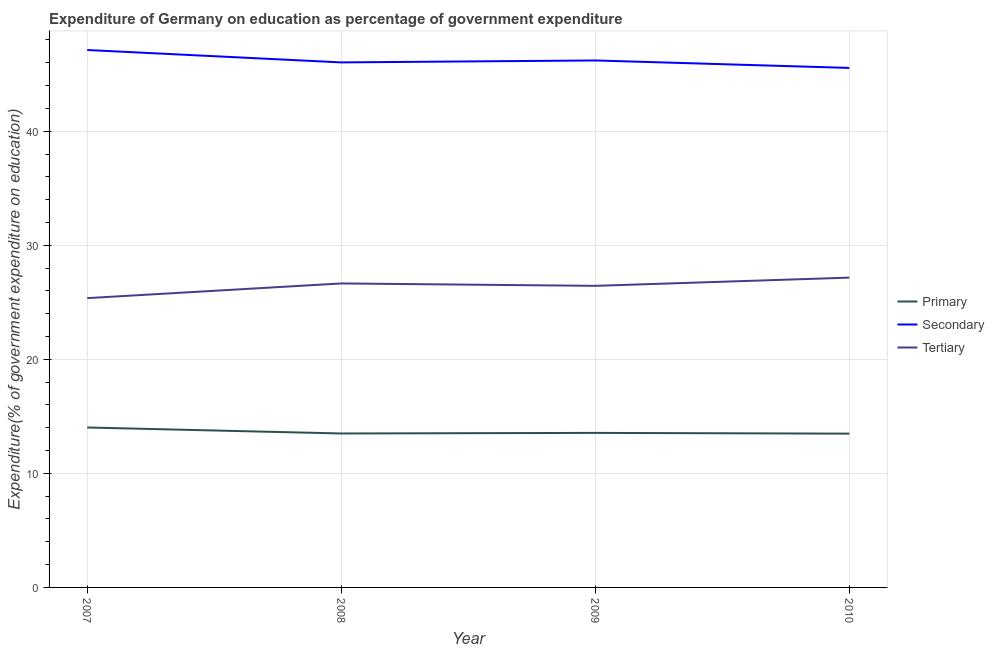Does the line corresponding to expenditure on secondary education intersect with the line corresponding to expenditure on primary education?
Keep it short and to the point. No. What is the expenditure on secondary education in 2007?
Offer a very short reply. 47.12. Across all years, what is the maximum expenditure on primary education?
Give a very brief answer. 14.02. Across all years, what is the minimum expenditure on primary education?
Keep it short and to the point. 13.48. In which year was the expenditure on tertiary education maximum?
Offer a terse response. 2010. In which year was the expenditure on tertiary education minimum?
Give a very brief answer. 2007. What is the total expenditure on tertiary education in the graph?
Give a very brief answer. 105.62. What is the difference between the expenditure on secondary education in 2007 and that in 2010?
Offer a very short reply. 1.57. What is the difference between the expenditure on primary education in 2007 and the expenditure on tertiary education in 2008?
Offer a very short reply. -12.63. What is the average expenditure on primary education per year?
Provide a short and direct response. 13.64. In the year 2009, what is the difference between the expenditure on secondary education and expenditure on tertiary education?
Offer a very short reply. 19.76. In how many years, is the expenditure on primary education greater than 12 %?
Offer a very short reply. 4. What is the ratio of the expenditure on secondary education in 2009 to that in 2010?
Ensure brevity in your answer.  1.01. Is the expenditure on tertiary education in 2008 less than that in 2010?
Your answer should be very brief. Yes. Is the difference between the expenditure on secondary education in 2009 and 2010 greater than the difference between the expenditure on primary education in 2009 and 2010?
Make the answer very short. Yes. What is the difference between the highest and the second highest expenditure on secondary education?
Keep it short and to the point. 0.92. What is the difference between the highest and the lowest expenditure on primary education?
Offer a terse response. 0.54. In how many years, is the expenditure on primary education greater than the average expenditure on primary education taken over all years?
Provide a succinct answer. 1. Is the sum of the expenditure on tertiary education in 2008 and 2010 greater than the maximum expenditure on secondary education across all years?
Offer a very short reply. Yes. Is the expenditure on primary education strictly greater than the expenditure on tertiary education over the years?
Your answer should be compact. No. Are the values on the major ticks of Y-axis written in scientific E-notation?
Make the answer very short. No. Does the graph contain any zero values?
Offer a very short reply. No. What is the title of the graph?
Provide a succinct answer. Expenditure of Germany on education as percentage of government expenditure. Does "Industry" appear as one of the legend labels in the graph?
Your answer should be compact. No. What is the label or title of the X-axis?
Give a very brief answer. Year. What is the label or title of the Y-axis?
Offer a very short reply. Expenditure(% of government expenditure on education). What is the Expenditure(% of government expenditure on education) in Primary in 2007?
Your response must be concise. 14.02. What is the Expenditure(% of government expenditure on education) in Secondary in 2007?
Your answer should be compact. 47.12. What is the Expenditure(% of government expenditure on education) of Tertiary in 2007?
Your response must be concise. 25.36. What is the Expenditure(% of government expenditure on education) in Primary in 2008?
Your answer should be very brief. 13.5. What is the Expenditure(% of government expenditure on education) in Secondary in 2008?
Keep it short and to the point. 46.03. What is the Expenditure(% of government expenditure on education) of Tertiary in 2008?
Provide a short and direct response. 26.65. What is the Expenditure(% of government expenditure on education) in Primary in 2009?
Keep it short and to the point. 13.55. What is the Expenditure(% of government expenditure on education) in Secondary in 2009?
Give a very brief answer. 46.2. What is the Expenditure(% of government expenditure on education) of Tertiary in 2009?
Provide a short and direct response. 26.44. What is the Expenditure(% of government expenditure on education) in Primary in 2010?
Ensure brevity in your answer.  13.48. What is the Expenditure(% of government expenditure on education) of Secondary in 2010?
Ensure brevity in your answer.  45.55. What is the Expenditure(% of government expenditure on education) of Tertiary in 2010?
Your answer should be compact. 27.16. Across all years, what is the maximum Expenditure(% of government expenditure on education) in Primary?
Ensure brevity in your answer.  14.02. Across all years, what is the maximum Expenditure(% of government expenditure on education) of Secondary?
Provide a short and direct response. 47.12. Across all years, what is the maximum Expenditure(% of government expenditure on education) in Tertiary?
Make the answer very short. 27.16. Across all years, what is the minimum Expenditure(% of government expenditure on education) of Primary?
Keep it short and to the point. 13.48. Across all years, what is the minimum Expenditure(% of government expenditure on education) in Secondary?
Keep it short and to the point. 45.55. Across all years, what is the minimum Expenditure(% of government expenditure on education) of Tertiary?
Ensure brevity in your answer.  25.36. What is the total Expenditure(% of government expenditure on education) in Primary in the graph?
Give a very brief answer. 54.55. What is the total Expenditure(% of government expenditure on education) in Secondary in the graph?
Give a very brief answer. 184.9. What is the total Expenditure(% of government expenditure on education) of Tertiary in the graph?
Your answer should be compact. 105.62. What is the difference between the Expenditure(% of government expenditure on education) of Primary in 2007 and that in 2008?
Offer a very short reply. 0.53. What is the difference between the Expenditure(% of government expenditure on education) of Secondary in 2007 and that in 2008?
Your answer should be very brief. 1.09. What is the difference between the Expenditure(% of government expenditure on education) of Tertiary in 2007 and that in 2008?
Your response must be concise. -1.29. What is the difference between the Expenditure(% of government expenditure on education) in Primary in 2007 and that in 2009?
Keep it short and to the point. 0.47. What is the difference between the Expenditure(% of government expenditure on education) in Secondary in 2007 and that in 2009?
Give a very brief answer. 0.92. What is the difference between the Expenditure(% of government expenditure on education) of Tertiary in 2007 and that in 2009?
Your answer should be compact. -1.08. What is the difference between the Expenditure(% of government expenditure on education) in Primary in 2007 and that in 2010?
Offer a terse response. 0.54. What is the difference between the Expenditure(% of government expenditure on education) in Secondary in 2007 and that in 2010?
Give a very brief answer. 1.57. What is the difference between the Expenditure(% of government expenditure on education) of Tertiary in 2007 and that in 2010?
Your answer should be very brief. -1.8. What is the difference between the Expenditure(% of government expenditure on education) in Primary in 2008 and that in 2009?
Provide a short and direct response. -0.05. What is the difference between the Expenditure(% of government expenditure on education) in Secondary in 2008 and that in 2009?
Offer a very short reply. -0.17. What is the difference between the Expenditure(% of government expenditure on education) in Tertiary in 2008 and that in 2009?
Provide a short and direct response. 0.21. What is the difference between the Expenditure(% of government expenditure on education) of Primary in 2008 and that in 2010?
Your answer should be very brief. 0.01. What is the difference between the Expenditure(% of government expenditure on education) of Secondary in 2008 and that in 2010?
Your answer should be compact. 0.48. What is the difference between the Expenditure(% of government expenditure on education) in Tertiary in 2008 and that in 2010?
Provide a succinct answer. -0.51. What is the difference between the Expenditure(% of government expenditure on education) in Primary in 2009 and that in 2010?
Offer a terse response. 0.07. What is the difference between the Expenditure(% of government expenditure on education) of Secondary in 2009 and that in 2010?
Make the answer very short. 0.66. What is the difference between the Expenditure(% of government expenditure on education) in Tertiary in 2009 and that in 2010?
Ensure brevity in your answer.  -0.72. What is the difference between the Expenditure(% of government expenditure on education) in Primary in 2007 and the Expenditure(% of government expenditure on education) in Secondary in 2008?
Your answer should be very brief. -32.01. What is the difference between the Expenditure(% of government expenditure on education) of Primary in 2007 and the Expenditure(% of government expenditure on education) of Tertiary in 2008?
Your response must be concise. -12.63. What is the difference between the Expenditure(% of government expenditure on education) of Secondary in 2007 and the Expenditure(% of government expenditure on education) of Tertiary in 2008?
Your answer should be very brief. 20.47. What is the difference between the Expenditure(% of government expenditure on education) of Primary in 2007 and the Expenditure(% of government expenditure on education) of Secondary in 2009?
Keep it short and to the point. -32.18. What is the difference between the Expenditure(% of government expenditure on education) in Primary in 2007 and the Expenditure(% of government expenditure on education) in Tertiary in 2009?
Keep it short and to the point. -12.42. What is the difference between the Expenditure(% of government expenditure on education) of Secondary in 2007 and the Expenditure(% of government expenditure on education) of Tertiary in 2009?
Make the answer very short. 20.68. What is the difference between the Expenditure(% of government expenditure on education) of Primary in 2007 and the Expenditure(% of government expenditure on education) of Secondary in 2010?
Keep it short and to the point. -31.52. What is the difference between the Expenditure(% of government expenditure on education) of Primary in 2007 and the Expenditure(% of government expenditure on education) of Tertiary in 2010?
Your answer should be compact. -13.14. What is the difference between the Expenditure(% of government expenditure on education) of Secondary in 2007 and the Expenditure(% of government expenditure on education) of Tertiary in 2010?
Give a very brief answer. 19.96. What is the difference between the Expenditure(% of government expenditure on education) in Primary in 2008 and the Expenditure(% of government expenditure on education) in Secondary in 2009?
Your answer should be very brief. -32.71. What is the difference between the Expenditure(% of government expenditure on education) of Primary in 2008 and the Expenditure(% of government expenditure on education) of Tertiary in 2009?
Offer a very short reply. -12.94. What is the difference between the Expenditure(% of government expenditure on education) in Secondary in 2008 and the Expenditure(% of government expenditure on education) in Tertiary in 2009?
Provide a succinct answer. 19.59. What is the difference between the Expenditure(% of government expenditure on education) in Primary in 2008 and the Expenditure(% of government expenditure on education) in Secondary in 2010?
Provide a succinct answer. -32.05. What is the difference between the Expenditure(% of government expenditure on education) of Primary in 2008 and the Expenditure(% of government expenditure on education) of Tertiary in 2010?
Your response must be concise. -13.67. What is the difference between the Expenditure(% of government expenditure on education) of Secondary in 2008 and the Expenditure(% of government expenditure on education) of Tertiary in 2010?
Ensure brevity in your answer.  18.87. What is the difference between the Expenditure(% of government expenditure on education) in Primary in 2009 and the Expenditure(% of government expenditure on education) in Secondary in 2010?
Provide a succinct answer. -32. What is the difference between the Expenditure(% of government expenditure on education) of Primary in 2009 and the Expenditure(% of government expenditure on education) of Tertiary in 2010?
Offer a terse response. -13.61. What is the difference between the Expenditure(% of government expenditure on education) in Secondary in 2009 and the Expenditure(% of government expenditure on education) in Tertiary in 2010?
Give a very brief answer. 19.04. What is the average Expenditure(% of government expenditure on education) in Primary per year?
Provide a succinct answer. 13.64. What is the average Expenditure(% of government expenditure on education) of Secondary per year?
Make the answer very short. 46.23. What is the average Expenditure(% of government expenditure on education) in Tertiary per year?
Ensure brevity in your answer.  26.41. In the year 2007, what is the difference between the Expenditure(% of government expenditure on education) in Primary and Expenditure(% of government expenditure on education) in Secondary?
Give a very brief answer. -33.09. In the year 2007, what is the difference between the Expenditure(% of government expenditure on education) of Primary and Expenditure(% of government expenditure on education) of Tertiary?
Your response must be concise. -11.34. In the year 2007, what is the difference between the Expenditure(% of government expenditure on education) in Secondary and Expenditure(% of government expenditure on education) in Tertiary?
Provide a succinct answer. 21.75. In the year 2008, what is the difference between the Expenditure(% of government expenditure on education) in Primary and Expenditure(% of government expenditure on education) in Secondary?
Make the answer very short. -32.53. In the year 2008, what is the difference between the Expenditure(% of government expenditure on education) of Primary and Expenditure(% of government expenditure on education) of Tertiary?
Give a very brief answer. -13.16. In the year 2008, what is the difference between the Expenditure(% of government expenditure on education) in Secondary and Expenditure(% of government expenditure on education) in Tertiary?
Keep it short and to the point. 19.38. In the year 2009, what is the difference between the Expenditure(% of government expenditure on education) of Primary and Expenditure(% of government expenditure on education) of Secondary?
Give a very brief answer. -32.65. In the year 2009, what is the difference between the Expenditure(% of government expenditure on education) of Primary and Expenditure(% of government expenditure on education) of Tertiary?
Your answer should be very brief. -12.89. In the year 2009, what is the difference between the Expenditure(% of government expenditure on education) of Secondary and Expenditure(% of government expenditure on education) of Tertiary?
Ensure brevity in your answer.  19.76. In the year 2010, what is the difference between the Expenditure(% of government expenditure on education) in Primary and Expenditure(% of government expenditure on education) in Secondary?
Provide a succinct answer. -32.06. In the year 2010, what is the difference between the Expenditure(% of government expenditure on education) in Primary and Expenditure(% of government expenditure on education) in Tertiary?
Give a very brief answer. -13.68. In the year 2010, what is the difference between the Expenditure(% of government expenditure on education) of Secondary and Expenditure(% of government expenditure on education) of Tertiary?
Offer a terse response. 18.39. What is the ratio of the Expenditure(% of government expenditure on education) in Primary in 2007 to that in 2008?
Offer a very short reply. 1.04. What is the ratio of the Expenditure(% of government expenditure on education) of Secondary in 2007 to that in 2008?
Ensure brevity in your answer.  1.02. What is the ratio of the Expenditure(% of government expenditure on education) of Tertiary in 2007 to that in 2008?
Your response must be concise. 0.95. What is the ratio of the Expenditure(% of government expenditure on education) of Primary in 2007 to that in 2009?
Offer a terse response. 1.03. What is the ratio of the Expenditure(% of government expenditure on education) in Secondary in 2007 to that in 2009?
Keep it short and to the point. 1.02. What is the ratio of the Expenditure(% of government expenditure on education) of Tertiary in 2007 to that in 2009?
Offer a terse response. 0.96. What is the ratio of the Expenditure(% of government expenditure on education) of Primary in 2007 to that in 2010?
Make the answer very short. 1.04. What is the ratio of the Expenditure(% of government expenditure on education) of Secondary in 2007 to that in 2010?
Give a very brief answer. 1.03. What is the ratio of the Expenditure(% of government expenditure on education) of Tertiary in 2007 to that in 2010?
Provide a short and direct response. 0.93. What is the ratio of the Expenditure(% of government expenditure on education) of Primary in 2008 to that in 2009?
Provide a short and direct response. 1. What is the ratio of the Expenditure(% of government expenditure on education) in Secondary in 2008 to that in 2009?
Offer a very short reply. 1. What is the ratio of the Expenditure(% of government expenditure on education) of Primary in 2008 to that in 2010?
Your answer should be very brief. 1. What is the ratio of the Expenditure(% of government expenditure on education) in Secondary in 2008 to that in 2010?
Your answer should be compact. 1.01. What is the ratio of the Expenditure(% of government expenditure on education) of Tertiary in 2008 to that in 2010?
Provide a short and direct response. 0.98. What is the ratio of the Expenditure(% of government expenditure on education) of Secondary in 2009 to that in 2010?
Give a very brief answer. 1.01. What is the ratio of the Expenditure(% of government expenditure on education) of Tertiary in 2009 to that in 2010?
Provide a short and direct response. 0.97. What is the difference between the highest and the second highest Expenditure(% of government expenditure on education) of Primary?
Give a very brief answer. 0.47. What is the difference between the highest and the second highest Expenditure(% of government expenditure on education) in Secondary?
Provide a short and direct response. 0.92. What is the difference between the highest and the second highest Expenditure(% of government expenditure on education) of Tertiary?
Offer a terse response. 0.51. What is the difference between the highest and the lowest Expenditure(% of government expenditure on education) of Primary?
Ensure brevity in your answer.  0.54. What is the difference between the highest and the lowest Expenditure(% of government expenditure on education) of Secondary?
Provide a succinct answer. 1.57. What is the difference between the highest and the lowest Expenditure(% of government expenditure on education) of Tertiary?
Ensure brevity in your answer.  1.8. 